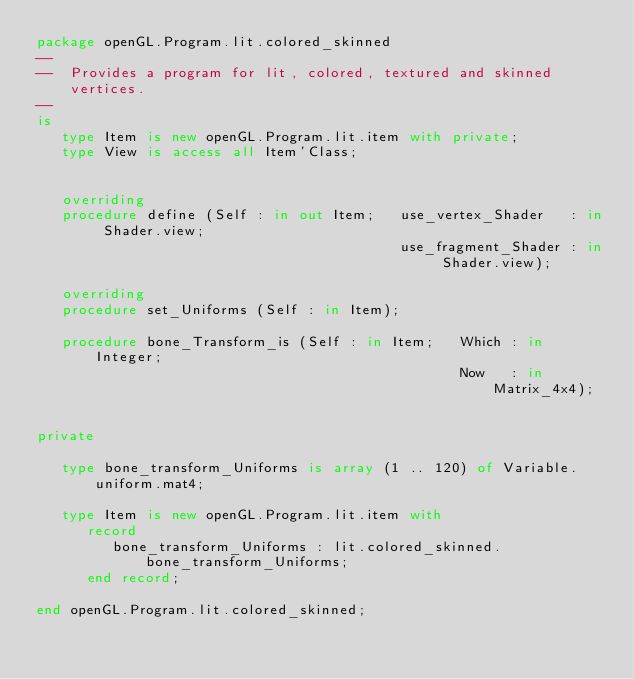Convert code to text. <code><loc_0><loc_0><loc_500><loc_500><_Ada_>package openGL.Program.lit.colored_skinned
--
--  Provides a program for lit, colored, textured and skinned vertices.
--
is
   type Item is new openGL.Program.lit.item with private;
   type View is access all Item'Class;


   overriding
   procedure define (Self : in out Item;   use_vertex_Shader   : in Shader.view;
                                           use_fragment_Shader : in Shader.view);

   overriding
   procedure set_Uniforms (Self : in Item);

   procedure bone_Transform_is (Self : in Item;   Which : in Integer;
                                                  Now   : in Matrix_4x4);


private

   type bone_transform_Uniforms is array (1 .. 120) of Variable.uniform.mat4;

   type Item is new openGL.Program.lit.item with
      record
         bone_transform_Uniforms : lit.colored_skinned.bone_transform_Uniforms;
      end record;

end openGL.Program.lit.colored_skinned;
</code> 